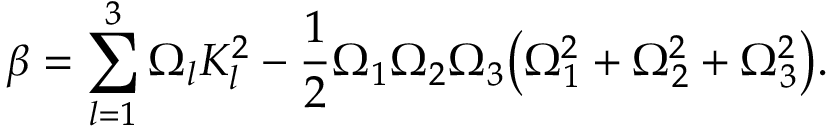Convert formula to latex. <formula><loc_0><loc_0><loc_500><loc_500>\beta = \sum _ { l = 1 } ^ { 3 } \Omega _ { l } K _ { l } ^ { 2 } - \frac { 1 } { 2 } \Omega _ { 1 } \Omega _ { 2 } \Omega _ { 3 } \left ( \Omega _ { 1 } ^ { 2 } + \Omega _ { 2 } ^ { 2 } + \Omega _ { 3 } ^ { 2 } \right ) .</formula> 